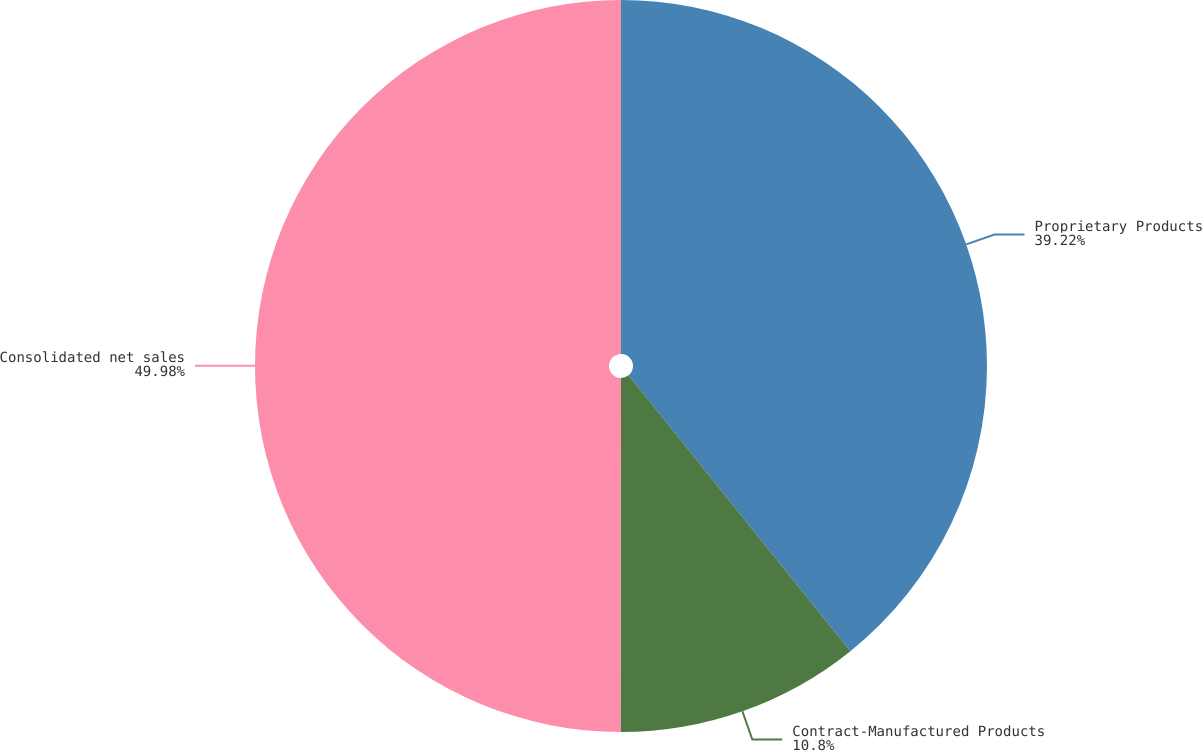<chart> <loc_0><loc_0><loc_500><loc_500><pie_chart><fcel>Proprietary Products<fcel>Contract-Manufactured Products<fcel>Consolidated net sales<nl><fcel>39.22%<fcel>10.8%<fcel>49.98%<nl></chart> 